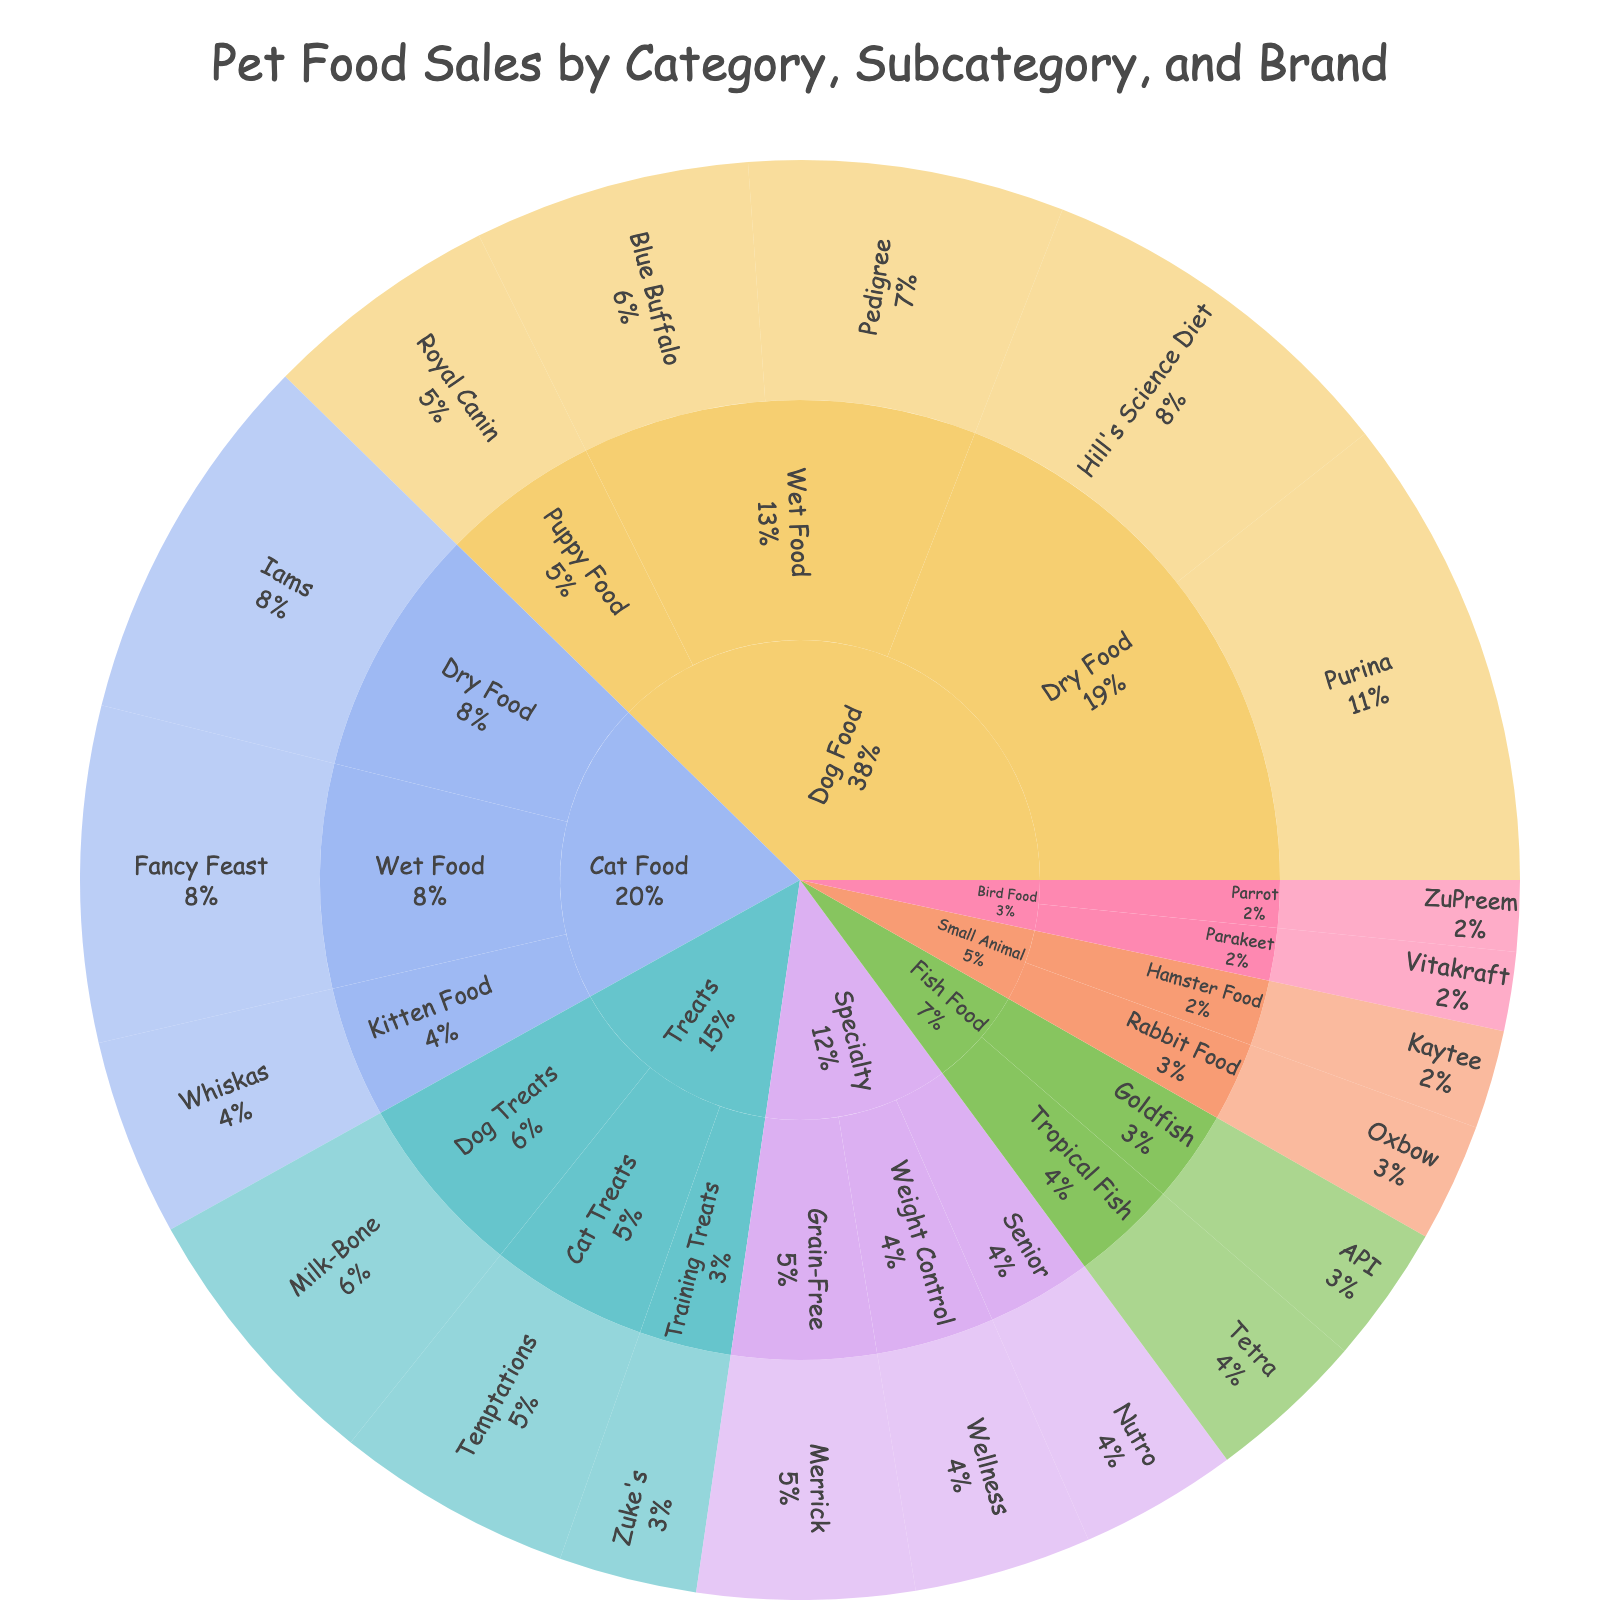What is the title of the figure? The title is usually prominently displayed at the top of the figure. In this case, it states the main topic of the plot.
Answer: Pet Food Sales by Category, Subcategory, and Brand Which category has the highest total sales? By looking at the various segments of the sunburst plot, we can identify which central section is the largest, indicating the highest total sales.
Answer: Dog Food How many subcategories are there within the "Specialty" category? Counting the slices that fall directly under the "Specialty" category will give the number of subcategories.
Answer: 3 Which brand has the highest sales in the "Cat Food" category? Within the "Cat Food" category's segment, we check the size of the individual brand segments to determine the largest one.
Answer: Iams What is the combined sales figure for "Dry Food" in the "Dog Food" category? Add the sales figures for Purina and Hill's Science Diet under "Dry Food" in the "Dog Food" category. 1200 + 950 = 2150
Answer: 2150 Which subcategory in "Treats" has the lowest sales? Within the "Treats" category, compare the sales in each subcategory and identify the smallest one.
Answer: Training Treats Are there more sales in "Grain-Free" or "Weight Control" under "Specialty"? Compare the sales figures for "Grain-Free" and "Weight Control" in the "Specialty" category. Grain-Free: 550, Weight Control: 450.
Answer: Grain-Free How many brands are listed under "Fish Food"? Count the number of segments that fall under "Fish Food".
Answer: 2 Which category or subcategory does the "Blue Buffalo" brand belong to? By following the path segments in the sunburst, we can trace Blue Buffalo to see its category and subcategory.
Answer: Dog Food, Wet Food What is the total sales value for all "Cat Food" subcategories combined? Sum up the sales for all subcategories under "Cat Food". 950 (Dry Food) + 850 (Wet Food) + 500 (Kitten Food) = 2300
Answer: 2300 